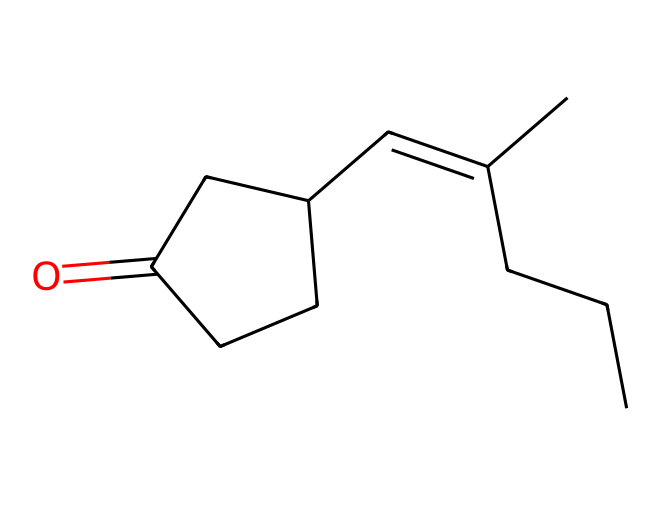What is the molecular formula of jasmone? To determine the molecular formula, count the number of each type of atom represented in the SMILES: there are 15 carbon atoms (C), 22 hydrogen atoms (H), and 1 oxygen atom (O). Thus, the molecular formula combines these counts.
Answer: C15H22O How many rings are present in the structure of jasmone? The SMILES indicates a cyclopentanone, meaning there is one ring (the "C1" indicates the start of a ring and "C1" indicates its closure).
Answer: one What functional group is present in jasmone? The structure contains a carbonyl group (C=O), characteristic of ketones. This group is indicated by the "O=" in the SMILES.
Answer: carbonyl How many double bonds are present in the structure of jasmone? By examining the structure closely, we see there is one double bond present in the chain (between C=C). This can be identified by the "=" in the SMILES.
Answer: one What type of ketone is jasmone? Jasmone is a cyclic ketone due to the presence of the ring structure (cyclopentanone) and the carbonyl group within that structure.
Answer: cyclic Which part of the structure gives jasmone its characteristic scent? The presence of the cyclopentanone structure, combined with the specific arrangement of carbon chains and functional groups, contributes to the scent, particularly the carbonyl part and the unsaturation (double bond).
Answer: cyclopentanone 